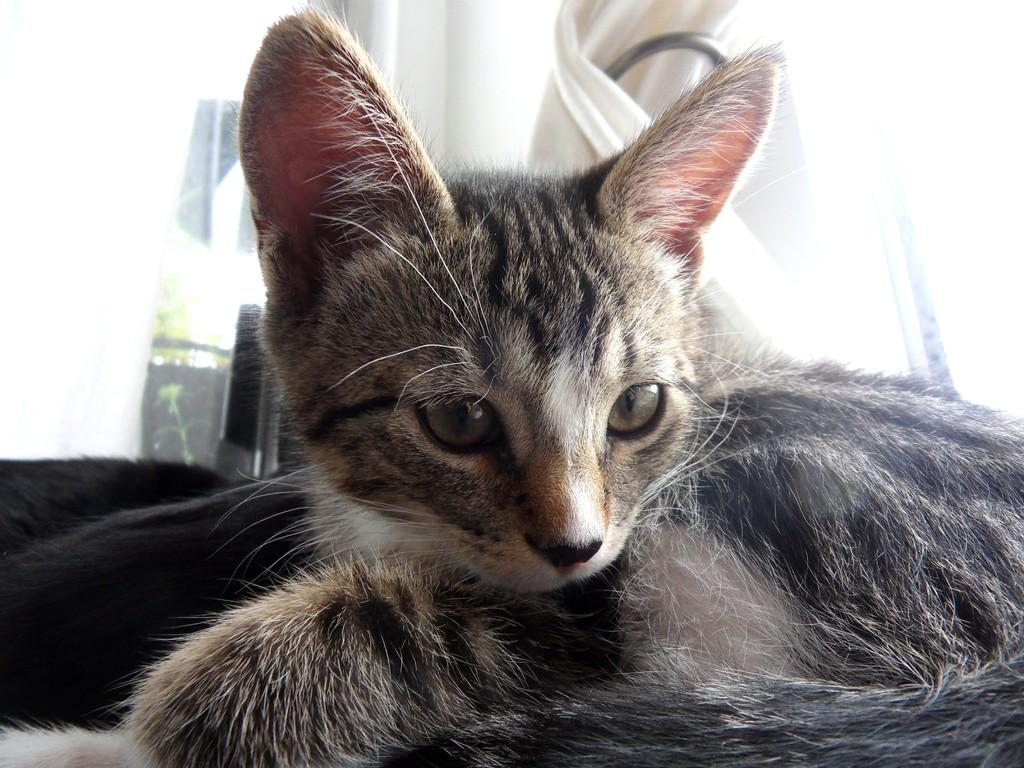What type of animal is present in the image? There is a cat on a surface in the image. What type of fabric is visible in the image? There is a curtain in the image. What type of vegetation is present in the image? There is a plant in the image. What type of structure is visible in the image? There is a wall in the image. What type of can is visible in the image? There is no can present in the image. What type of trousers is the cat wearing in the image? Cats do not wear trousers, and there is no indication of clothing in the image. 